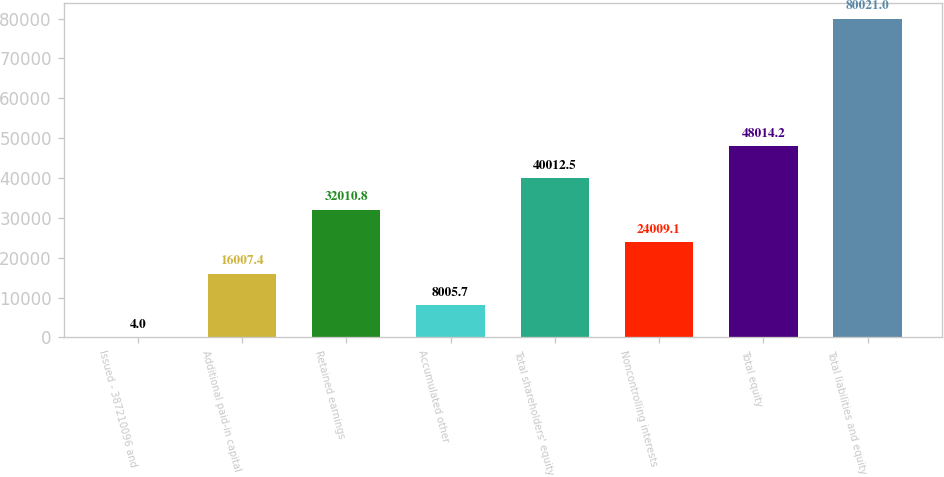Convert chart to OTSL. <chart><loc_0><loc_0><loc_500><loc_500><bar_chart><fcel>Issued - 387210096 and<fcel>Additional paid-in capital<fcel>Retained earnings<fcel>Accumulated other<fcel>Total shareholders' equity<fcel>Noncontrolling interests<fcel>Total equity<fcel>Total liabilities and equity<nl><fcel>4<fcel>16007.4<fcel>32010.8<fcel>8005.7<fcel>40012.5<fcel>24009.1<fcel>48014.2<fcel>80021<nl></chart> 